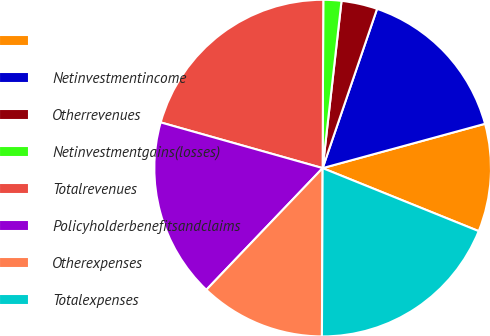<chart> <loc_0><loc_0><loc_500><loc_500><pie_chart><ecel><fcel>Netinvestmentincome<fcel>Otherrevenues<fcel>Netinvestmentgains(losses)<fcel>Totalrevenues<fcel>Policyholderbenefitsandclaims<fcel>Otherexpenses<fcel>Totalexpenses<nl><fcel>10.35%<fcel>15.52%<fcel>3.45%<fcel>1.73%<fcel>20.68%<fcel>17.24%<fcel>12.07%<fcel>18.96%<nl></chart> 